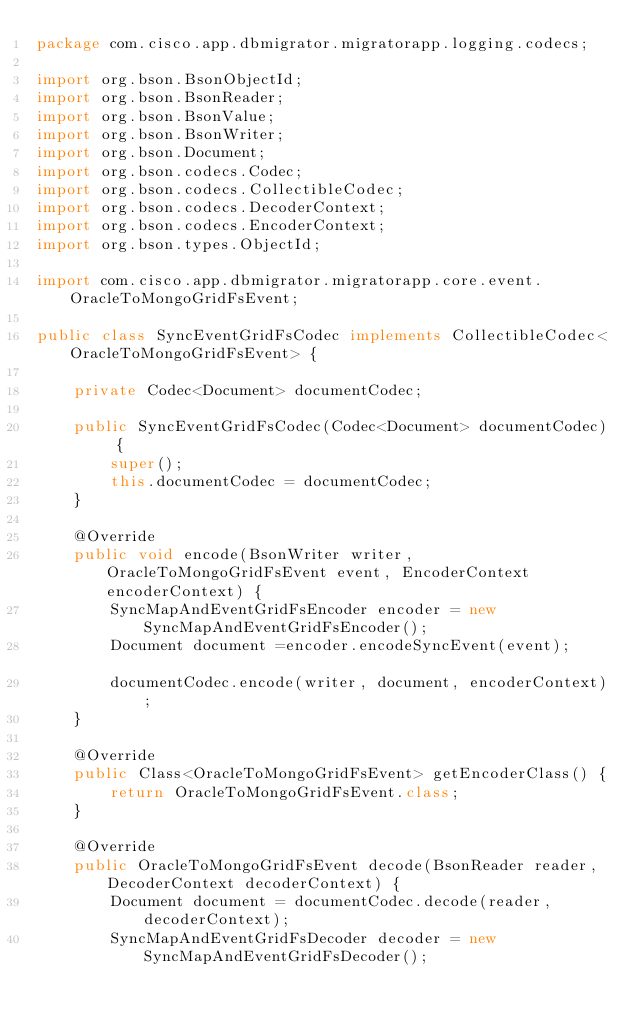Convert code to text. <code><loc_0><loc_0><loc_500><loc_500><_Java_>package com.cisco.app.dbmigrator.migratorapp.logging.codecs;

import org.bson.BsonObjectId;
import org.bson.BsonReader;
import org.bson.BsonValue;
import org.bson.BsonWriter;
import org.bson.Document;
import org.bson.codecs.Codec;
import org.bson.codecs.CollectibleCodec;
import org.bson.codecs.DecoderContext;
import org.bson.codecs.EncoderContext;
import org.bson.types.ObjectId;

import com.cisco.app.dbmigrator.migratorapp.core.event.OracleToMongoGridFsEvent;

public class SyncEventGridFsCodec implements CollectibleCodec<OracleToMongoGridFsEvent> {

	private Codec<Document> documentCodec;

	public SyncEventGridFsCodec(Codec<Document> documentCodec) {
		super();
		this.documentCodec = documentCodec;
	}
	
	@Override
	public void encode(BsonWriter writer, OracleToMongoGridFsEvent event, EncoderContext encoderContext) {
		SyncMapAndEventGridFsEncoder encoder = new SyncMapAndEventGridFsEncoder();		
		Document document =encoder.encodeSyncEvent(event);		
		documentCodec.encode(writer, document, encoderContext);
	}

	@Override
	public Class<OracleToMongoGridFsEvent> getEncoderClass() {
		return OracleToMongoGridFsEvent.class;
	}

	@Override
	public OracleToMongoGridFsEvent decode(BsonReader reader, DecoderContext decoderContext) {
		Document document = documentCodec.decode(reader, decoderContext);
		SyncMapAndEventGridFsDecoder decoder = new SyncMapAndEventGridFsDecoder();</code> 